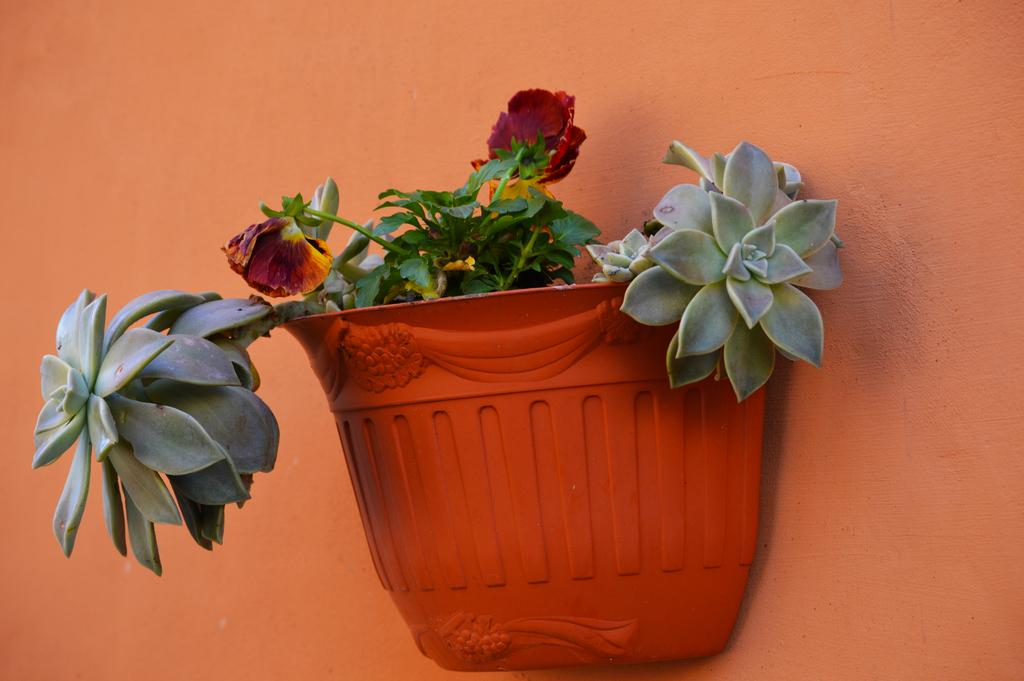What object is present in the image that holds a plant? There is a flower pot in the image that holds a plant. Can you describe the plant in the image? There is a plant in the image, but its specific characteristics are not mentioned in the facts. What can be seen in the background of the image? There is a wall in the background of the image. What type of mice can be seen interacting with the plant in the image? There are no mice present in the image, and therefore no such interaction can be observed. What religious symbolism is depicted in the image? There is no mention of any religious symbolism in the image. 